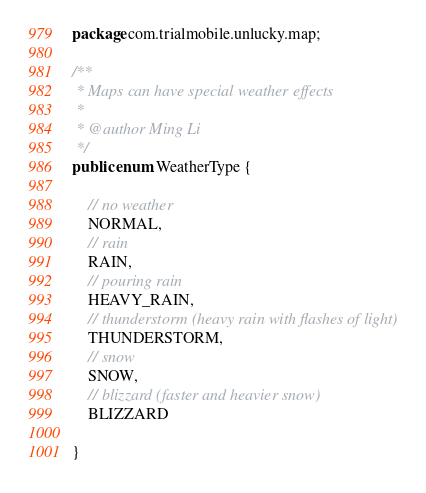Convert code to text. <code><loc_0><loc_0><loc_500><loc_500><_Java_>package com.trialmobile.unlucky.map;

/**
 * Maps can have special weather effects
 *
 * @author Ming Li
 */
public enum WeatherType {

    // no weather
    NORMAL,
    // rain
    RAIN,
    // pouring rain
    HEAVY_RAIN,
    // thunderstorm (heavy rain with flashes of light)
    THUNDERSTORM,
    // snow
    SNOW,
    // blizzard (faster and heavier snow)
    BLIZZARD

}
</code> 